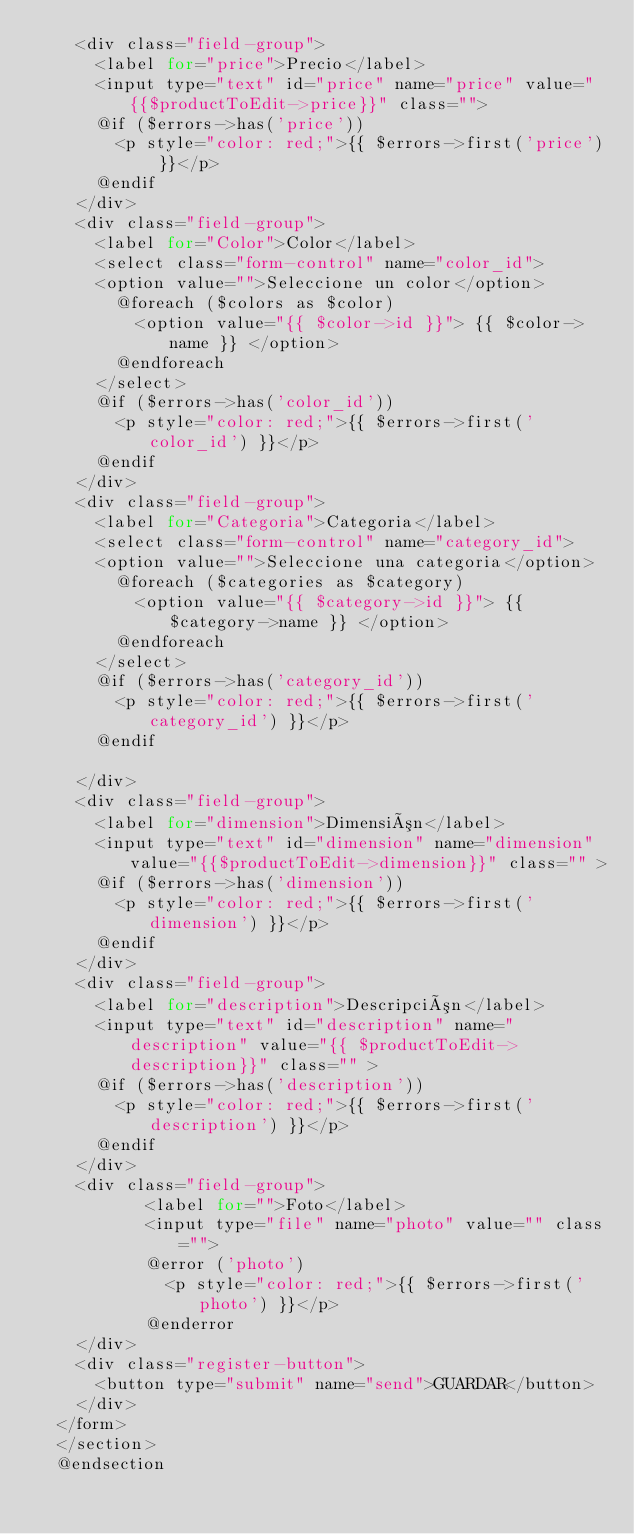Convert code to text. <code><loc_0><loc_0><loc_500><loc_500><_PHP_>    <div class="field-group">
      <label for="price">Precio</label>
      <input type="text" id="price" name="price" value="{{$productToEdit->price}}" class="">
      @if ($errors->has('price'))
        <p style="color: red;">{{ $errors->first('price') }}</p>
      @endif
    </div>
    <div class="field-group">
      <label for="Color">Color</label>
      <select class="form-control" name="color_id">
      <option value="">Seleccione un color</option>
        @foreach ($colors as $color)
          <option value="{{ $color->id }}"> {{ $color->name }} </option>
        @endforeach
      </select>
      @if ($errors->has('color_id'))
        <p style="color: red;">{{ $errors->first('color_id') }}</p>
      @endif
    </div>
    <div class="field-group">
      <label for="Categoria">Categoria</label>
      <select class="form-control" name="category_id">
      <option value="">Seleccione una categoria</option>
        @foreach ($categories as $category)
          <option value="{{ $category->id }}"> {{ $category->name }} </option>
        @endforeach
      </select>
      @if ($errors->has('category_id'))
        <p style="color: red;">{{ $errors->first('category_id') }}</p>
      @endif

    </div>
    <div class="field-group">
      <label for="dimension">Dimensión</label>
      <input type="text" id="dimension" name="dimension" value="{{$productToEdit->dimension}}" class="" >
      @if ($errors->has('dimension'))
        <p style="color: red;">{{ $errors->first('dimension') }}</p>
      @endif
    </div>
    <div class="field-group">
      <label for="description">Descripción</label>
      <input type="text" id="description" name="description" value="{{ $productToEdit->description}}" class="" >
      @if ($errors->has('description'))
        <p style="color: red;">{{ $errors->first('description') }}</p>
      @endif
    </div>
    <div class="field-group">
           <label for="">Foto</label>
           <input type="file" name="photo" value="" class="">
           @error ('photo')
             <p style="color: red;">{{ $errors->first('photo') }}</p>
           @enderror
    </div>
    <div class="register-button">
      <button type="submit" name="send">GUARDAR</button>
    </div>
  </form>
  </section>
  @endsection
</code> 